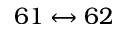Convert formula to latex. <formula><loc_0><loc_0><loc_500><loc_500>6 1 \leftrightarrow 6 2</formula> 